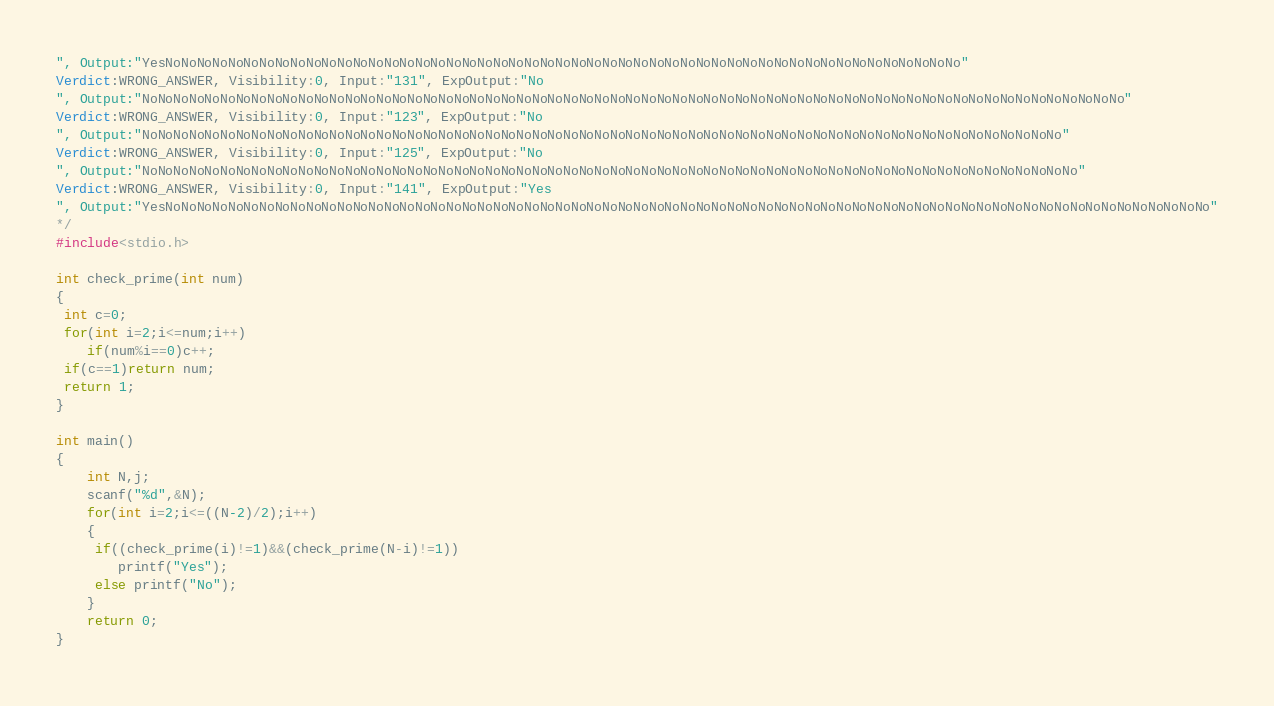Convert code to text. <code><loc_0><loc_0><loc_500><loc_500><_C_>", Output:"YesNoNoNoNoNoNoNoNoNoNoNoNoNoNoNoNoNoNoNoNoNoNoNoNoNoNoNoNoNoNoNoNoNoNoNoNoNoNoNoNoNoNoNoNoNoNoNoNoNoNoNo"
Verdict:WRONG_ANSWER, Visibility:0, Input:"131", ExpOutput:"No
", Output:"NoNoNoNoNoNoNoNoNoNoNoNoNoNoNoNoNoNoNoNoNoNoNoNoNoNoNoNoNoNoNoNoNoNoNoNoNoNoNoNoNoNoNoNoNoNoNoNoNoNoNoNoNoNoNoNoNoNoNoNoNoNoNo"
Verdict:WRONG_ANSWER, Visibility:0, Input:"123", ExpOutput:"No
", Output:"NoNoNoNoNoNoNoNoNoNoNoNoNoNoNoNoNoNoNoNoNoNoNoNoNoNoNoNoNoNoNoNoNoNoNoNoNoNoNoNoNoNoNoNoNoNoNoNoNoNoNoNoNoNoNoNoNoNoNo"
Verdict:WRONG_ANSWER, Visibility:0, Input:"125", ExpOutput:"No
", Output:"NoNoNoNoNoNoNoNoNoNoNoNoNoNoNoNoNoNoNoNoNoNoNoNoNoNoNoNoNoNoNoNoNoNoNoNoNoNoNoNoNoNoNoNoNoNoNoNoNoNoNoNoNoNoNoNoNoNoNoNo"
Verdict:WRONG_ANSWER, Visibility:0, Input:"141", ExpOutput:"Yes
", Output:"YesNoNoNoNoNoNoNoNoNoNoNoNoNoNoNoNoNoNoNoNoNoNoNoNoNoNoNoNoNoNoNoNoNoNoNoNoNoNoNoNoNoNoNoNoNoNoNoNoNoNoNoNoNoNoNoNoNoNoNoNoNoNoNoNoNoNoNo"
*/
#include<stdio.h>

int check_prime(int num)
{
 int c=0;
 for(int i=2;i<=num;i++)
    if(num%i==0)c++;
 if(c==1)return num;
 return 1;
}

int main()
{
    int N,j;
	scanf("%d",&N);
	for(int i=2;i<=((N-2)/2);i++)
	{
	 if((check_prime(i)!=1)&&(check_prime(N-i)!=1))	 
	    printf("Yes");
	 else printf("No");   
	}    
	return 0;
}</code> 